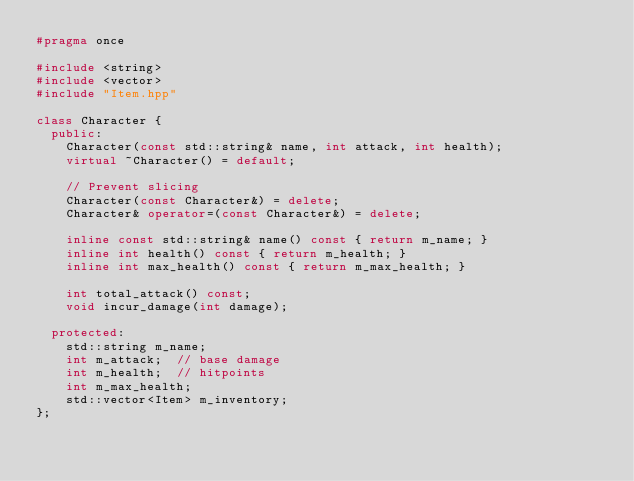Convert code to text. <code><loc_0><loc_0><loc_500><loc_500><_C++_>#pragma once

#include <string>
#include <vector>
#include "Item.hpp"

class Character {
  public:
    Character(const std::string& name, int attack, int health);
    virtual ~Character() = default;

    // Prevent slicing
    Character(const Character&) = delete;
    Character& operator=(const Character&) = delete;

    inline const std::string& name() const { return m_name; }
    inline int health() const { return m_health; }
    inline int max_health() const { return m_max_health; }

    int total_attack() const;
    void incur_damage(int damage);

  protected:
    std::string m_name;
    int m_attack;  // base damage
    int m_health;  // hitpoints
    int m_max_health;
    std::vector<Item> m_inventory;
};</code> 